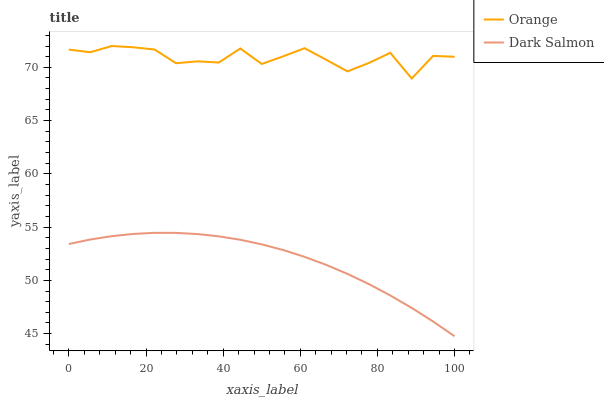Does Dark Salmon have the minimum area under the curve?
Answer yes or no. Yes. Does Orange have the maximum area under the curve?
Answer yes or no. Yes. Does Dark Salmon have the maximum area under the curve?
Answer yes or no. No. Is Dark Salmon the smoothest?
Answer yes or no. Yes. Is Orange the roughest?
Answer yes or no. Yes. Is Dark Salmon the roughest?
Answer yes or no. No. Does Dark Salmon have the lowest value?
Answer yes or no. Yes. Does Orange have the highest value?
Answer yes or no. Yes. Does Dark Salmon have the highest value?
Answer yes or no. No. Is Dark Salmon less than Orange?
Answer yes or no. Yes. Is Orange greater than Dark Salmon?
Answer yes or no. Yes. Does Dark Salmon intersect Orange?
Answer yes or no. No. 